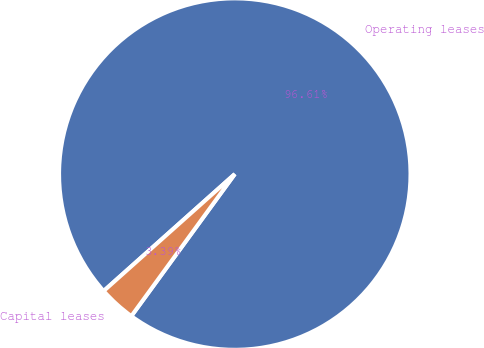Convert chart to OTSL. <chart><loc_0><loc_0><loc_500><loc_500><pie_chart><fcel>Operating leases<fcel>Capital leases<nl><fcel>96.61%<fcel>3.39%<nl></chart> 